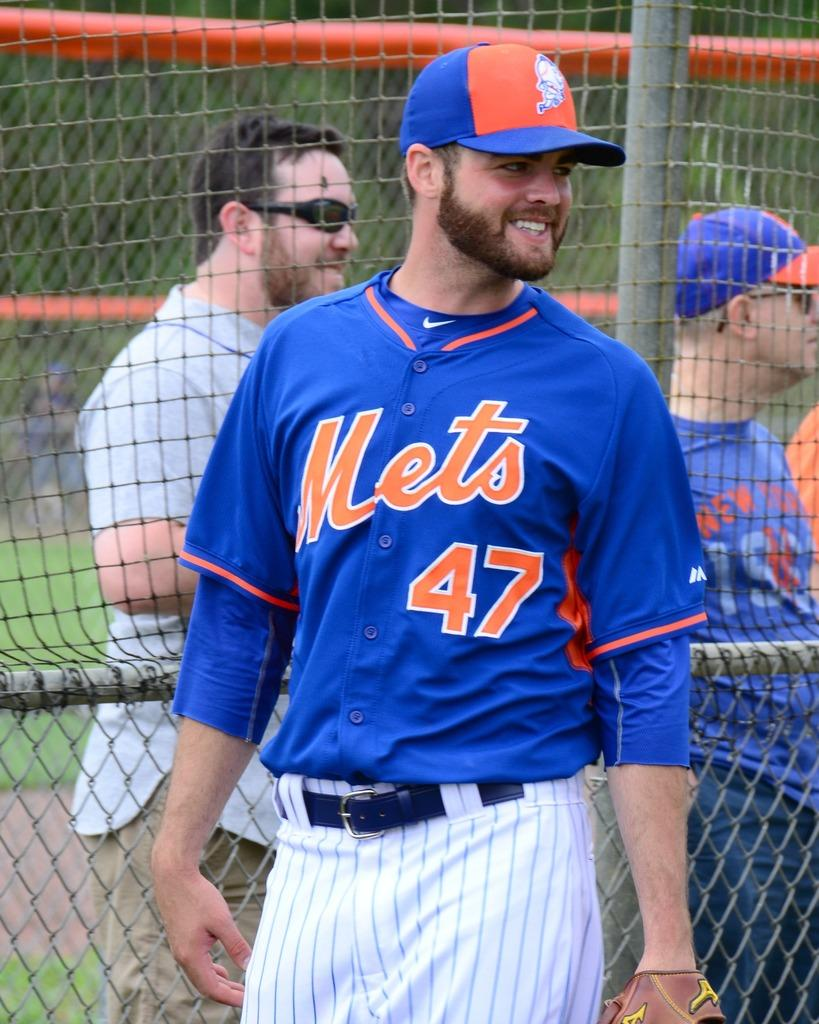Provide a one-sentence caption for the provided image. A man in a blue Mets jersey stands and smiles with his head turned. 